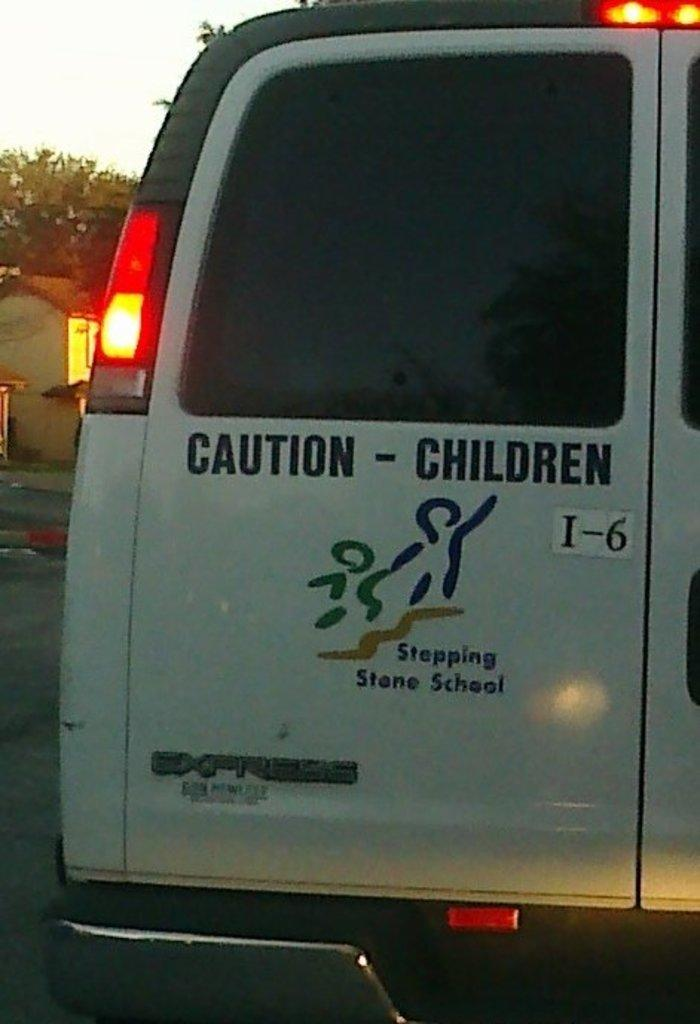What type of vehicle is in the image? There is a van in the image. What feature of the van is mentioned in the facts? The van has doors. What structure is located on the left side of the image? There is a small house on the left side of the image. What type of natural elements can be seen in the image? There are trees in the image. How much was the payment for the van in the image? There is no information about the payment for the van in the image or the provided facts. 